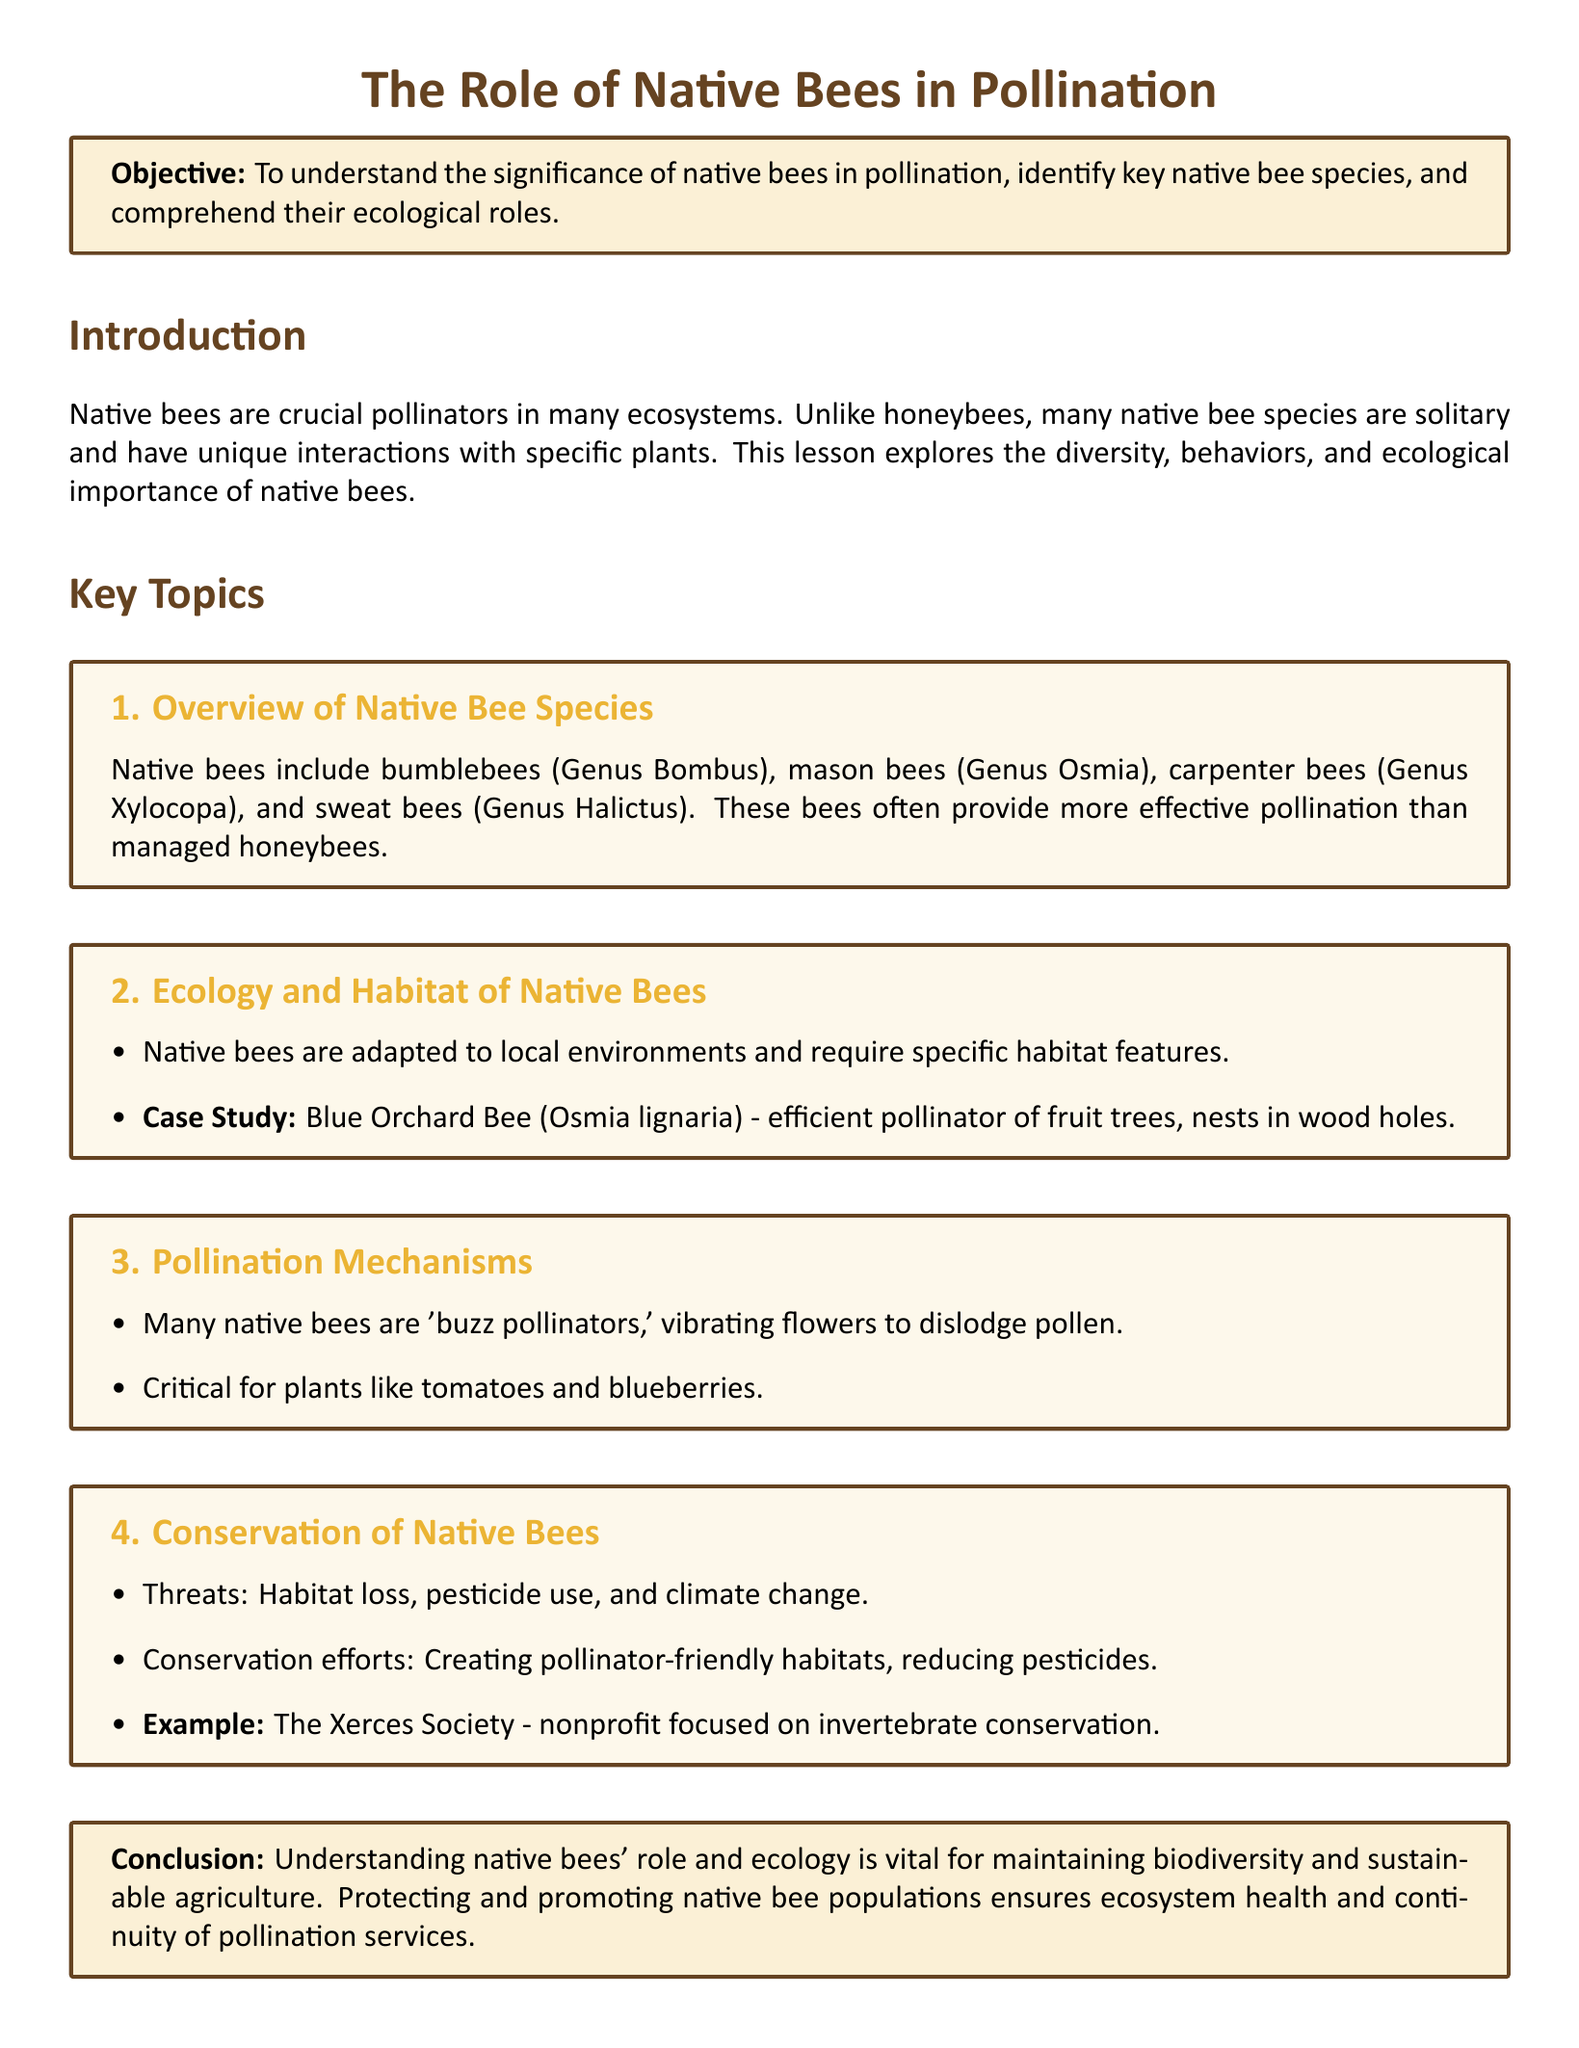What is the main objective of the lesson? The objective states the aim of the lesson, which is to understand the significance of native bees in pollination and their ecological roles.
Answer: To understand the significance of native bees in pollination, identify key native bee species, and comprehend their ecological roles What is the genus of bumblebees? The document provides the classification of bumblebees within the context of native bee species.
Answer: Bombus What is one example of a native bee studied for its pollination efficiency? The case study mentioned in the document highlights a specific native bee known for its role in pollination.
Answer: Blue Orchard Bee (Osmia lignaria) What is one of the threats to native bees mentioned? This question addresses a specific threat outlined in the conservation section of the lesson plan.
Answer: Habitat loss What type of pollination mechanisms do many native bees perform? This inquiry seeks to identify a specific characteristic of native bee behavior related to their pollination techniques.
Answer: Buzz pollinators What is an example of a plant that benefits from native bee pollination? The document provides examples of plant species that rely on native bee species for effective pollination.
Answer: Tomatoes What organization is focused on invertebrate conservation? This question looks for the name of an organization mentioned in the context of conservation efforts for native bees.
Answer: The Xerces Society How are native bees adapted to their environment? The document implies certain ecological traits of native bees that enable them to thrive in local habitats.
Answer: Require specific habitat features What is one conservation effort for native bees mentioned in the lesson? This question addresses a specific action taken to support the survival and conservation of native bee populations.
Answer: Creating pollinator-friendly habitats 